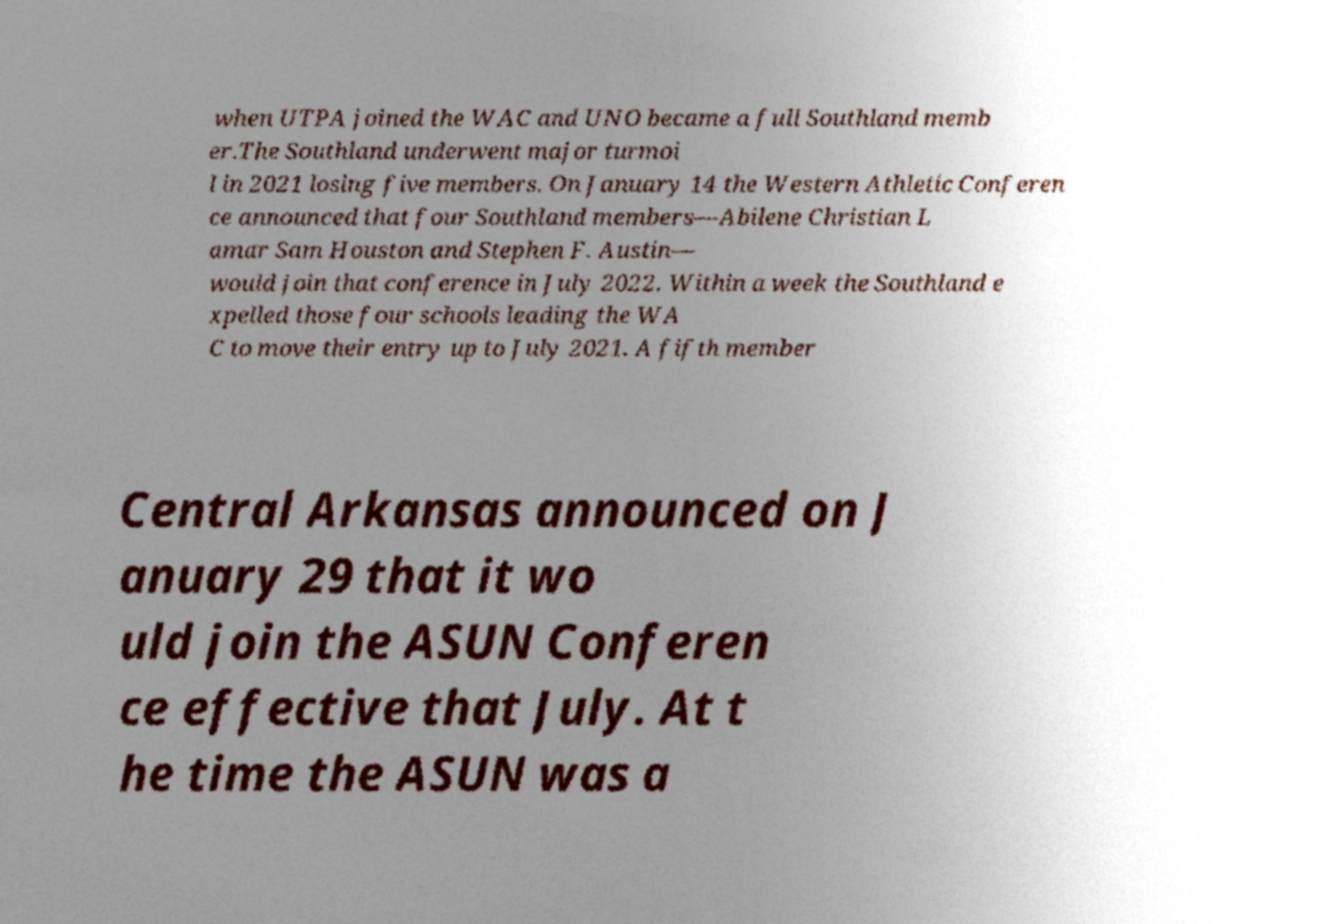There's text embedded in this image that I need extracted. Can you transcribe it verbatim? when UTPA joined the WAC and UNO became a full Southland memb er.The Southland underwent major turmoi l in 2021 losing five members. On January 14 the Western Athletic Conferen ce announced that four Southland members—Abilene Christian L amar Sam Houston and Stephen F. Austin— would join that conference in July 2022. Within a week the Southland e xpelled those four schools leading the WA C to move their entry up to July 2021. A fifth member Central Arkansas announced on J anuary 29 that it wo uld join the ASUN Conferen ce effective that July. At t he time the ASUN was a 